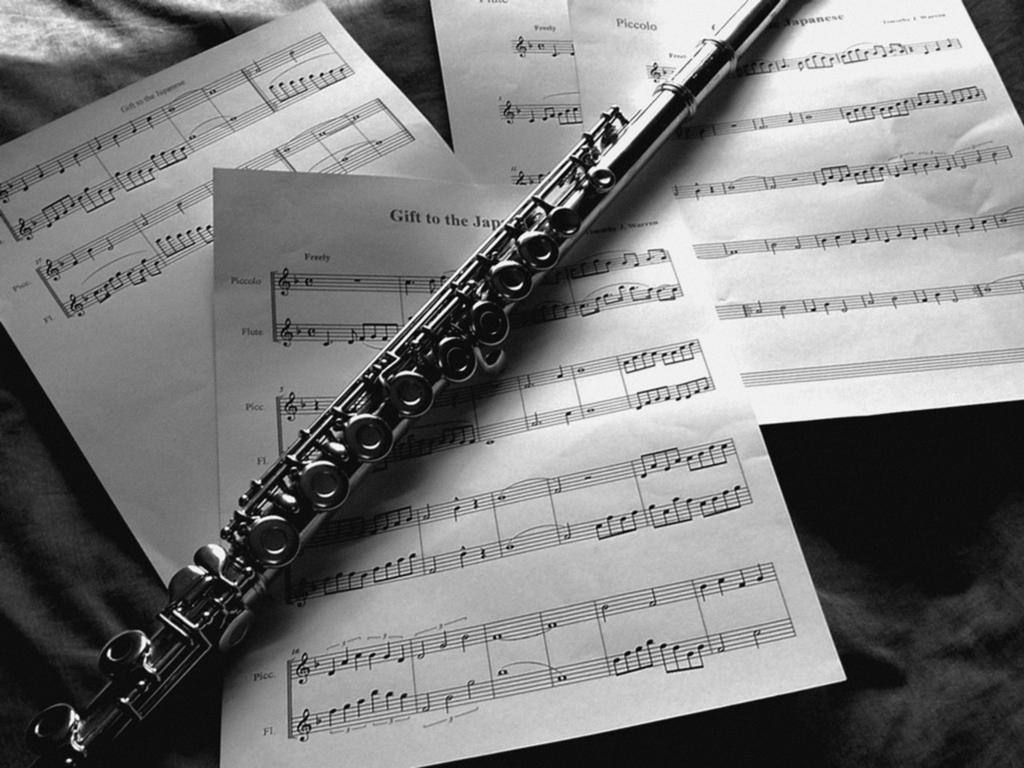What musical instrument is visible in the image? There is a flute in the image. What type of material is used for the flute? The flute is typically made of metal or wood, but the specific material cannot be determined from the image. What else is present on the table with the flute? There are papers with musical notes in the image. What might the papers with musical notes be used for? The papers with musical notes might be used for practicing or learning a musical piece. What type of blade is being sharpened on the table in the image? There is no blade present in the image; it only features a flute and papers with musical notes. 